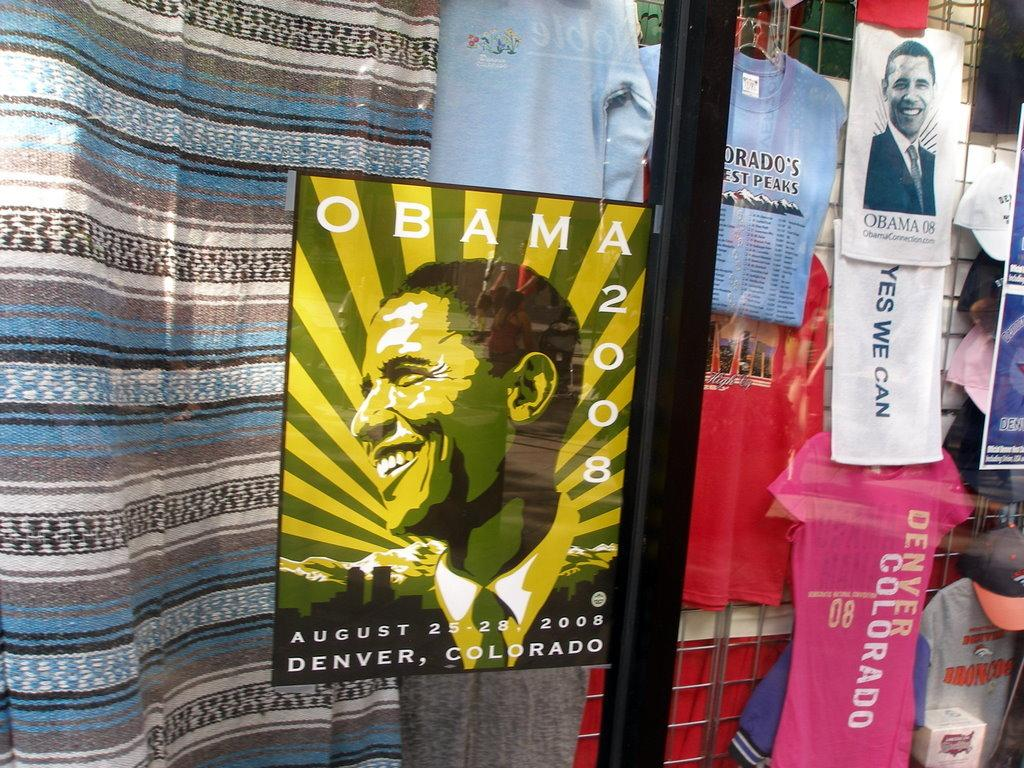<image>
Provide a brief description of the given image. A storefront selling Obama 2008 commemorative memorabilia in poster, towel, and shirt form 